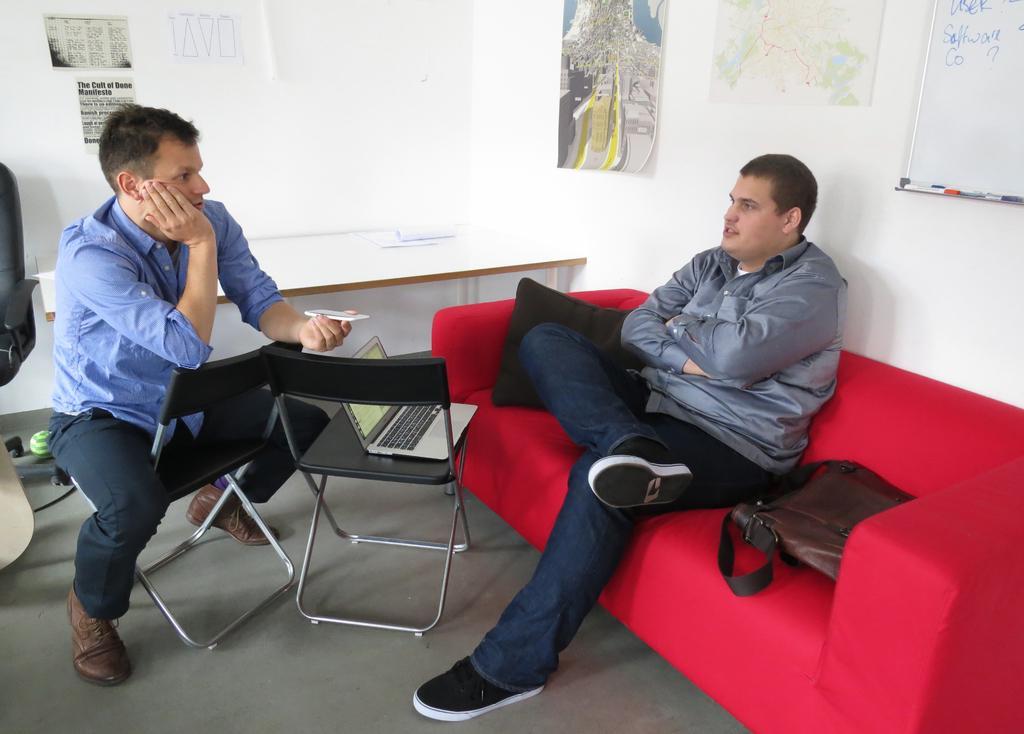Can you describe this image briefly? There are two men in this picture, one is sitting in the sofa and one is in the chair. In front of them there is a laptop placed in the chair. In the background, there is a white marker board attached to the wall and some photographs here. 